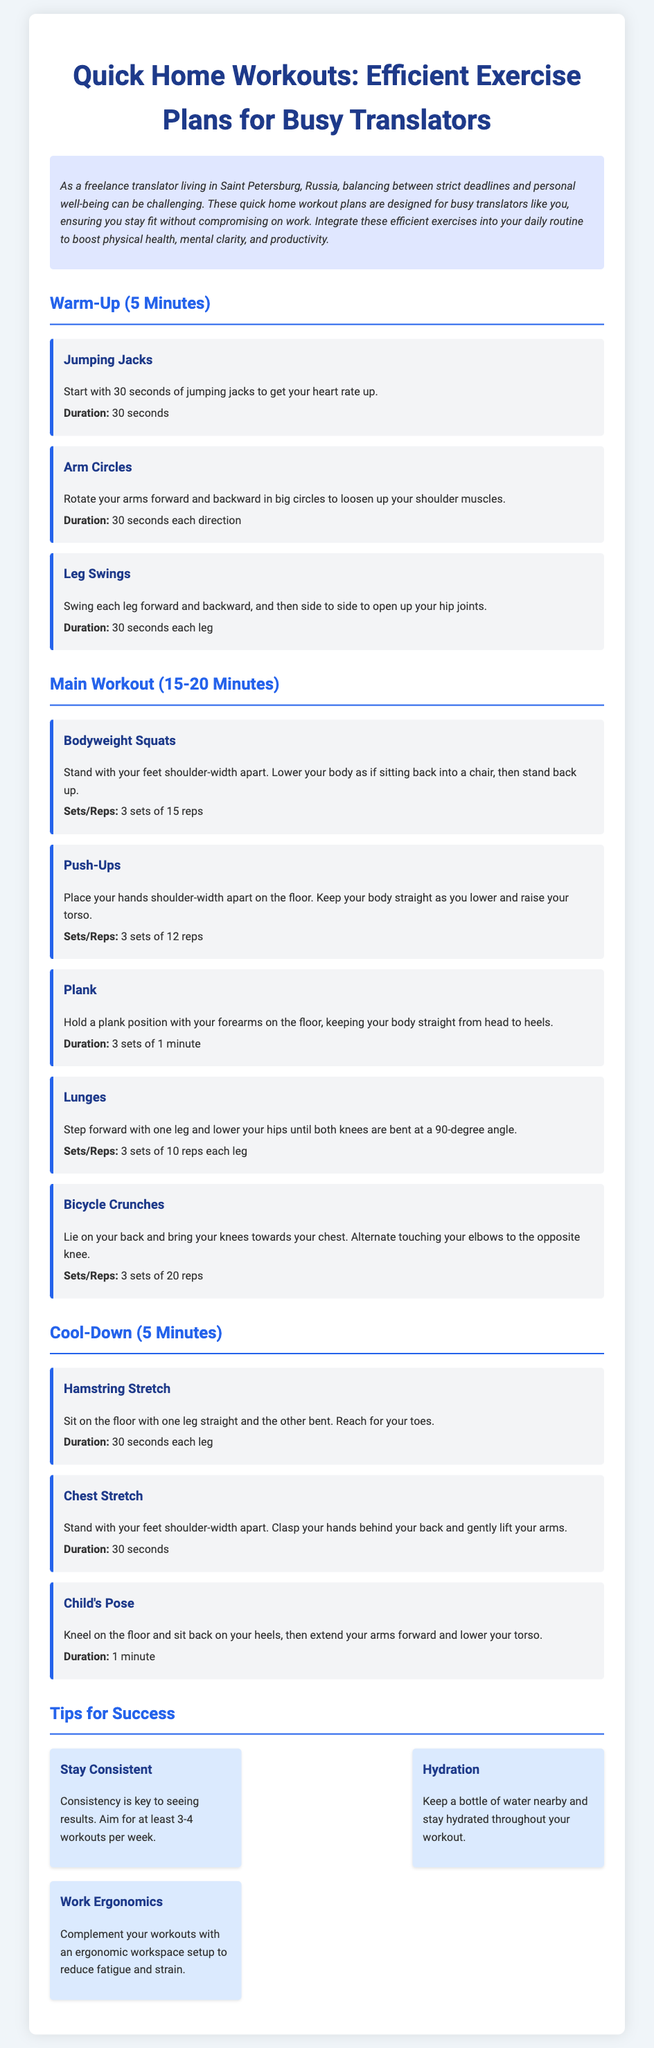What is the duration of the warm-up? The warm-up section states it lasts for 5 minutes.
Answer: 5 minutes How many sets of push-ups are recommended? The document specifies 3 sets of 12 reps for push-ups.
Answer: 3 sets of 12 reps What is the first exercise listed in the main workout? The first exercise in the main workout section is bodyweight squats.
Answer: Bodyweight Squats How long should you hold a plank? The document mentions holding a plank for 1 minute in 3 sets.
Answer: 1 minute What is one tip for success in the workout plan? The document lists "Stay Consistent" as one of the tips for success.
Answer: Stay Consistent How many exercises are included in the cool-down section? The cool-down section has three exercises listed.
Answer: Three What is the primary audience for these workouts? The introduction clarifies that these workouts are designed for busy translators.
Answer: Busy translators What is the last exercise of the cool-down section? The last exercise listed in the cool-down section is Child's Pose.
Answer: Child's Pose 